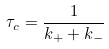Convert formula to latex. <formula><loc_0><loc_0><loc_500><loc_500>\tau _ { c } = \frac { 1 } { k _ { + } + k _ { - } }</formula> 